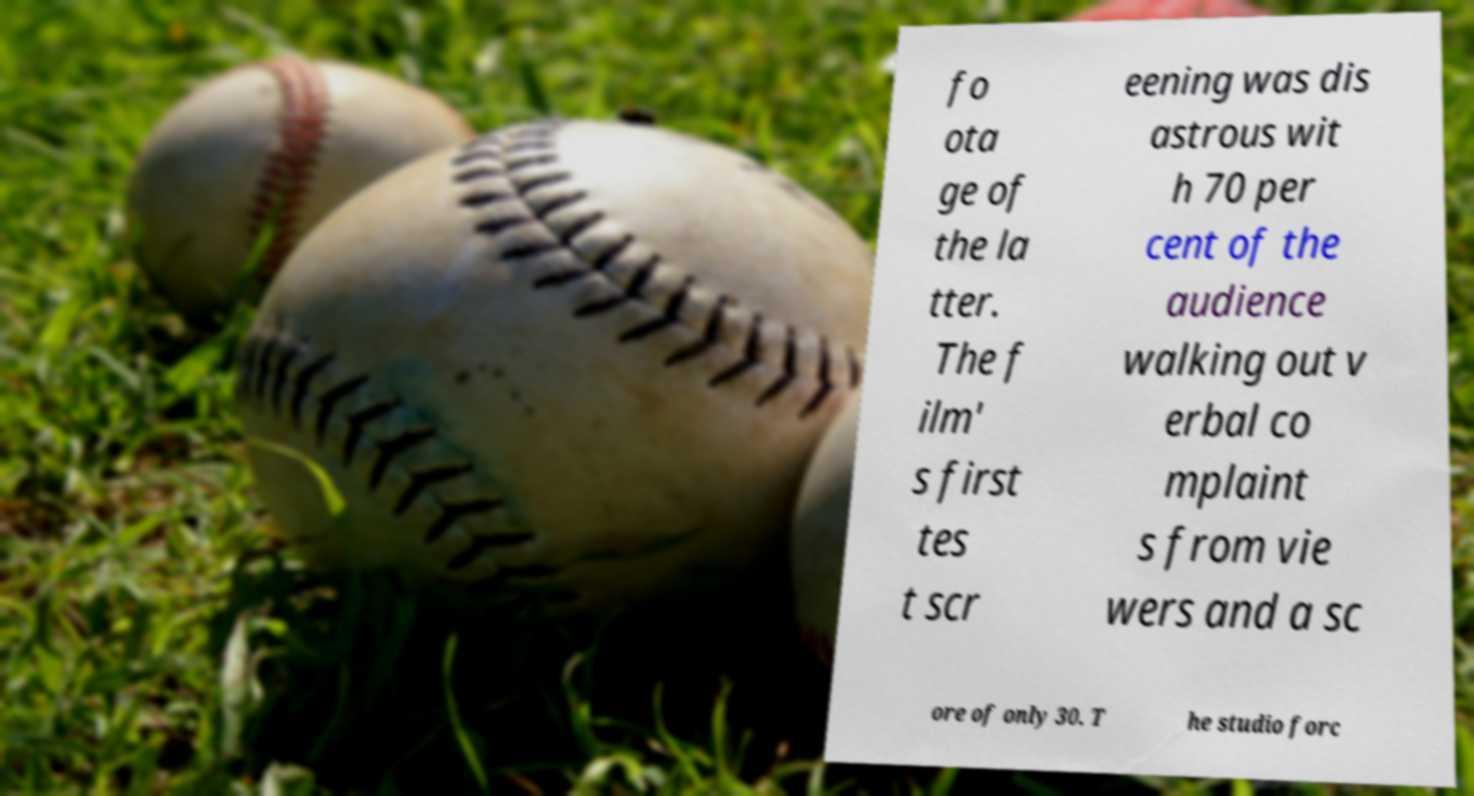Please identify and transcribe the text found in this image. fo ota ge of the la tter. The f ilm' s first tes t scr eening was dis astrous wit h 70 per cent of the audience walking out v erbal co mplaint s from vie wers and a sc ore of only 30. T he studio forc 